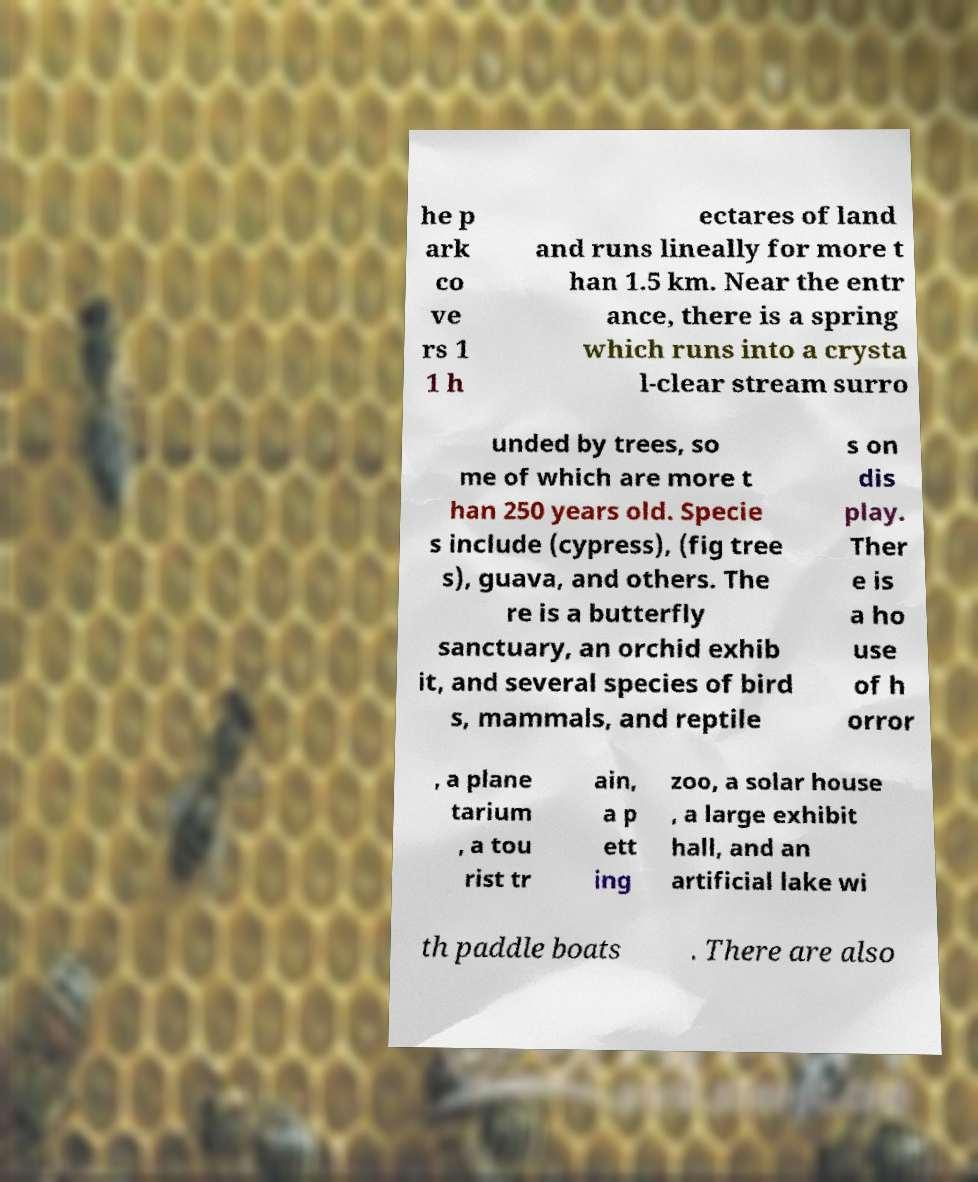What messages or text are displayed in this image? I need them in a readable, typed format. he p ark co ve rs 1 1 h ectares of land and runs lineally for more t han 1.5 km. Near the entr ance, there is a spring which runs into a crysta l-clear stream surro unded by trees, so me of which are more t han 250 years old. Specie s include (cypress), (fig tree s), guava, and others. The re is a butterfly sanctuary, an orchid exhib it, and several species of bird s, mammals, and reptile s on dis play. Ther e is a ho use of h orror , a plane tarium , a tou rist tr ain, a p ett ing zoo, a solar house , a large exhibit hall, and an artificial lake wi th paddle boats . There are also 